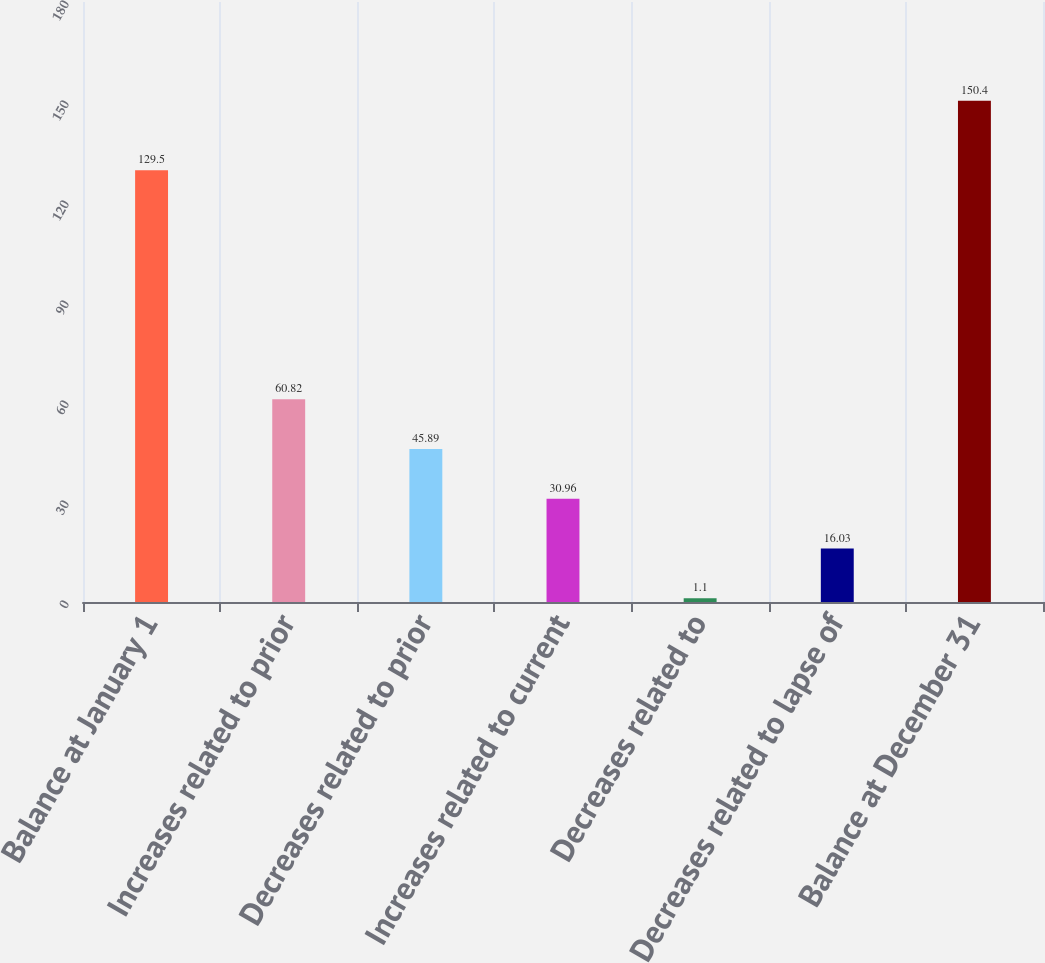<chart> <loc_0><loc_0><loc_500><loc_500><bar_chart><fcel>Balance at January 1<fcel>Increases related to prior<fcel>Decreases related to prior<fcel>Increases related to current<fcel>Decreases related to<fcel>Decreases related to lapse of<fcel>Balance at December 31<nl><fcel>129.5<fcel>60.82<fcel>45.89<fcel>30.96<fcel>1.1<fcel>16.03<fcel>150.4<nl></chart> 